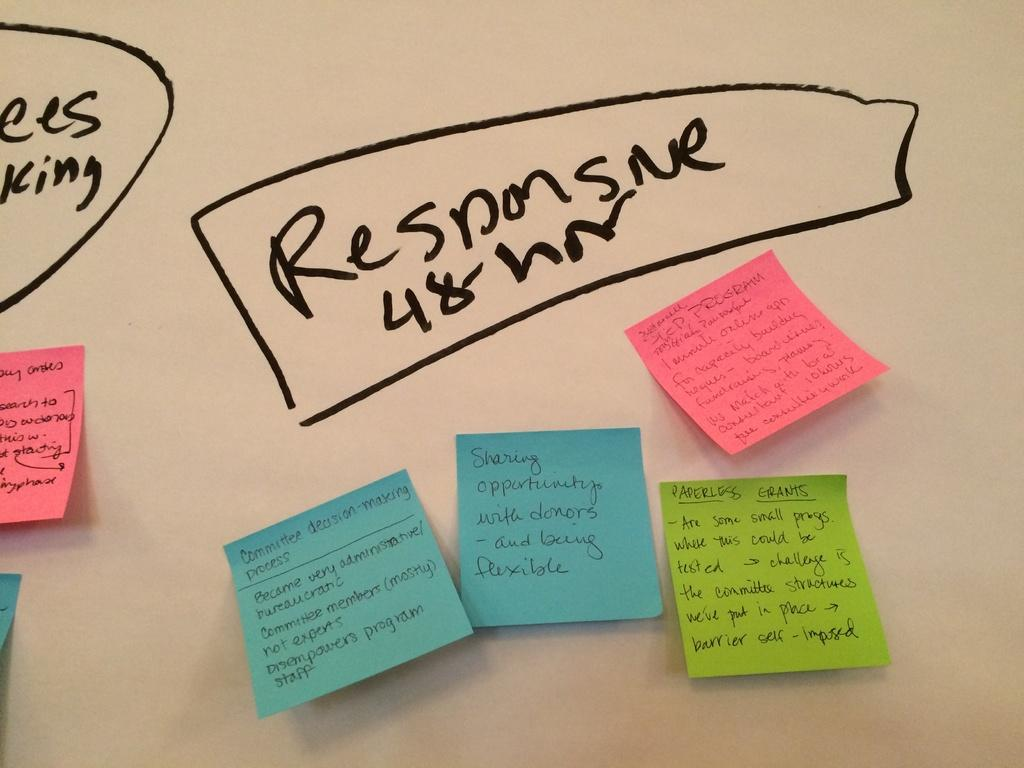What is written on the wall in the image? There is writing on the wall in the image. Can you describe the other writing materials in the image? There are different colored papers with writing on them in the image. Are there any slaves depicted in the image? There is no mention or depiction of slaves in the image. What type of orange can be seen in the image? There is no orange present in the image. 